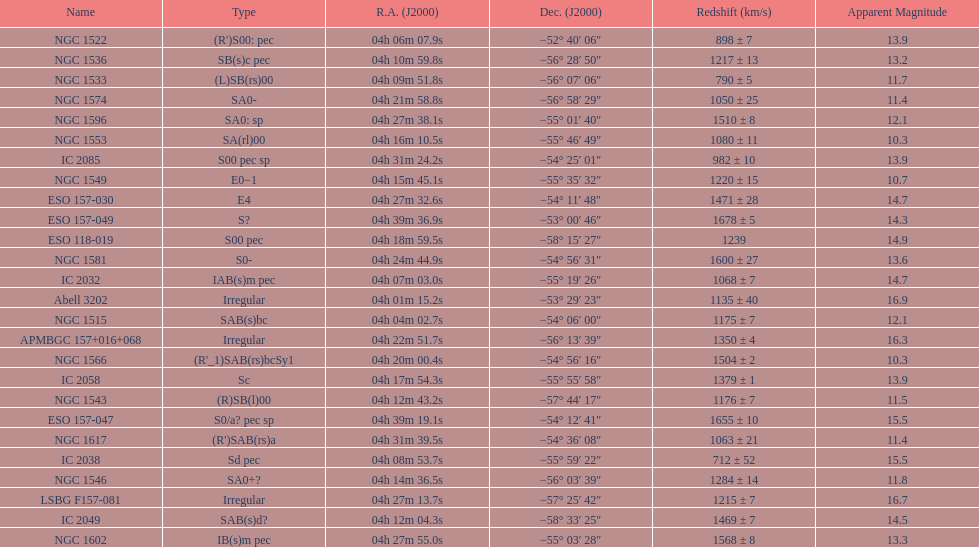What number of "irregular" types are there? 3. Could you help me parse every detail presented in this table? {'header': ['Name', 'Type', 'R.A. (J2000)', 'Dec. (J2000)', 'Redshift (km/s)', 'Apparent Magnitude'], 'rows': [['NGC 1522', "(R')S00: pec", '04h\xa006m\xa007.9s', '−52°\xa040′\xa006″', '898 ± 7', '13.9'], ['NGC 1536', 'SB(s)c pec', '04h\xa010m\xa059.8s', '−56°\xa028′\xa050″', '1217 ± 13', '13.2'], ['NGC 1533', '(L)SB(rs)00', '04h\xa009m\xa051.8s', '−56°\xa007′\xa006″', '790 ± 5', '11.7'], ['NGC 1574', 'SA0-', '04h\xa021m\xa058.8s', '−56°\xa058′\xa029″', '1050 ± 25', '11.4'], ['NGC 1596', 'SA0: sp', '04h\xa027m\xa038.1s', '−55°\xa001′\xa040″', '1510 ± 8', '12.1'], ['NGC 1553', 'SA(rl)00', '04h\xa016m\xa010.5s', '−55°\xa046′\xa049″', '1080 ± 11', '10.3'], ['IC 2085', 'S00 pec sp', '04h\xa031m\xa024.2s', '−54°\xa025′\xa001″', '982 ± 10', '13.9'], ['NGC 1549', 'E0−1', '04h\xa015m\xa045.1s', '−55°\xa035′\xa032″', '1220 ± 15', '10.7'], ['ESO 157-030', 'E4', '04h\xa027m\xa032.6s', '−54°\xa011′\xa048″', '1471 ± 28', '14.7'], ['ESO 157-049', 'S?', '04h\xa039m\xa036.9s', '−53°\xa000′\xa046″', '1678 ± 5', '14.3'], ['ESO 118-019', 'S00 pec', '04h\xa018m\xa059.5s', '−58°\xa015′\xa027″', '1239', '14.9'], ['NGC 1581', 'S0-', '04h\xa024m\xa044.9s', '−54°\xa056′\xa031″', '1600 ± 27', '13.6'], ['IC 2032', 'IAB(s)m pec', '04h\xa007m\xa003.0s', '−55°\xa019′\xa026″', '1068 ± 7', '14.7'], ['Abell 3202', 'Irregular', '04h\xa001m\xa015.2s', '−53°\xa029′\xa023″', '1135 ± 40', '16.9'], ['NGC 1515', 'SAB(s)bc', '04h\xa004m\xa002.7s', '−54°\xa006′\xa000″', '1175 ± 7', '12.1'], ['APMBGC 157+016+068', 'Irregular', '04h\xa022m\xa051.7s', '−56°\xa013′\xa039″', '1350 ± 4', '16.3'], ['NGC 1566', "(R'_1)SAB(rs)bcSy1", '04h\xa020m\xa000.4s', '−54°\xa056′\xa016″', '1504 ± 2', '10.3'], ['IC 2058', 'Sc', '04h\xa017m\xa054.3s', '−55°\xa055′\xa058″', '1379 ± 1', '13.9'], ['NGC 1543', '(R)SB(l)00', '04h\xa012m\xa043.2s', '−57°\xa044′\xa017″', '1176 ± 7', '11.5'], ['ESO 157-047', 'S0/a? pec sp', '04h\xa039m\xa019.1s', '−54°\xa012′\xa041″', '1655 ± 10', '15.5'], ['NGC 1617', "(R')SAB(rs)a", '04h\xa031m\xa039.5s', '−54°\xa036′\xa008″', '1063 ± 21', '11.4'], ['IC 2038', 'Sd pec', '04h\xa008m\xa053.7s', '−55°\xa059′\xa022″', '712 ± 52', '15.5'], ['NGC 1546', 'SA0+?', '04h\xa014m\xa036.5s', '−56°\xa003′\xa039″', '1284 ± 14', '11.8'], ['LSBG F157-081', 'Irregular', '04h\xa027m\xa013.7s', '−57°\xa025′\xa042″', '1215 ± 7', '16.7'], ['IC 2049', 'SAB(s)d?', '04h\xa012m\xa004.3s', '−58°\xa033′\xa025″', '1469 ± 7', '14.5'], ['NGC 1602', 'IB(s)m pec', '04h\xa027m\xa055.0s', '−55°\xa003′\xa028″', '1568 ± 8', '13.3']]} 